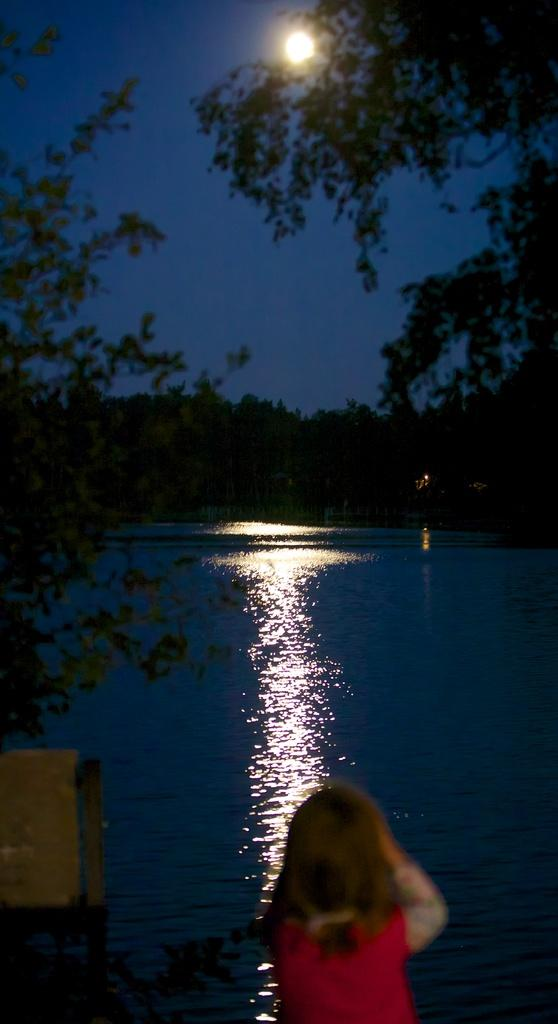Who or what is present in the image? There is a person in the image. What is the person wearing? The person is wearing a red dress. What can be seen in the background of the image? There is water visible in the background of the image. What celestial body is visible in the image? The moon is visible in the image. What is the color of the sky in the image? The sky is blue in color. What type of education is the person pursuing in the image? There is no indication of the person pursuing any education in the image. Can you see a gate in the image? There is no gate visible in the image. 